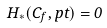Convert formula to latex. <formula><loc_0><loc_0><loc_500><loc_500>H _ { * } ( C _ { f } , p t ) = 0</formula> 